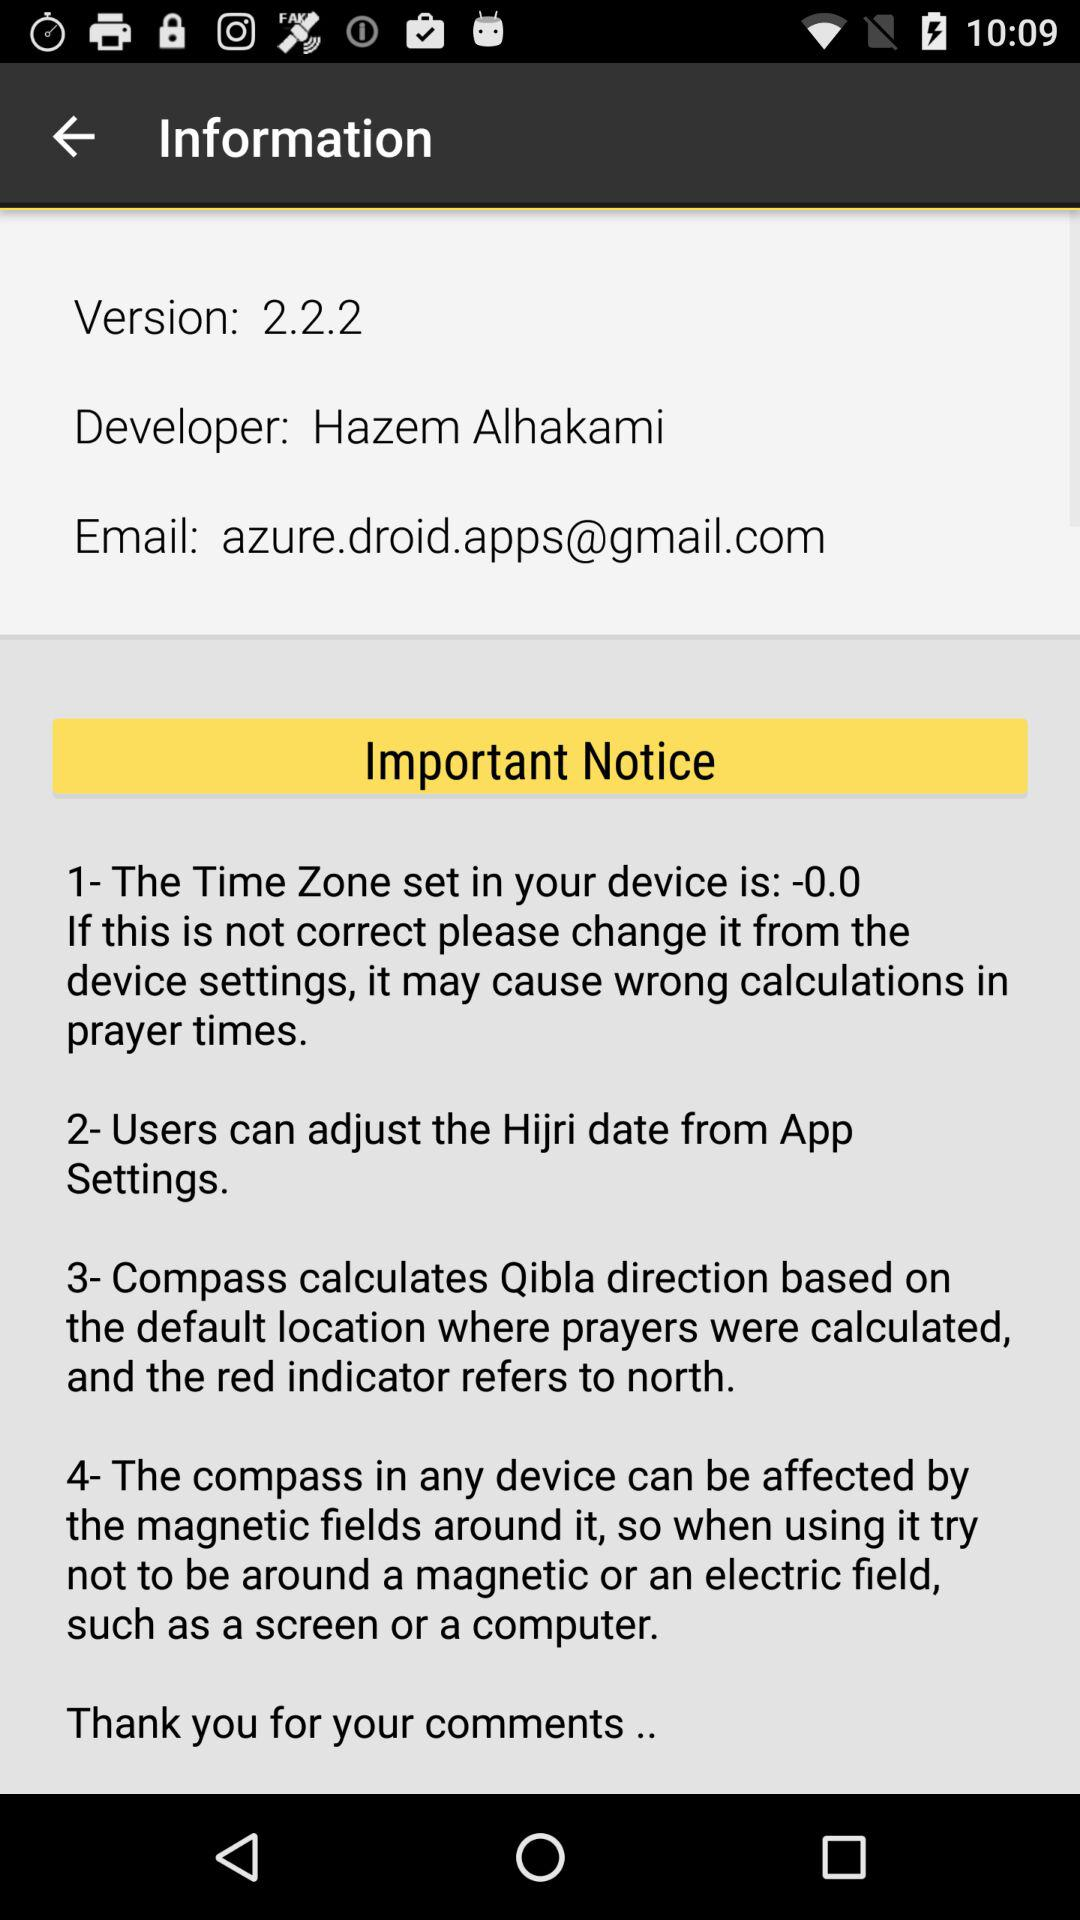What is the developer name? The developer name is Hazem Alhakami. 